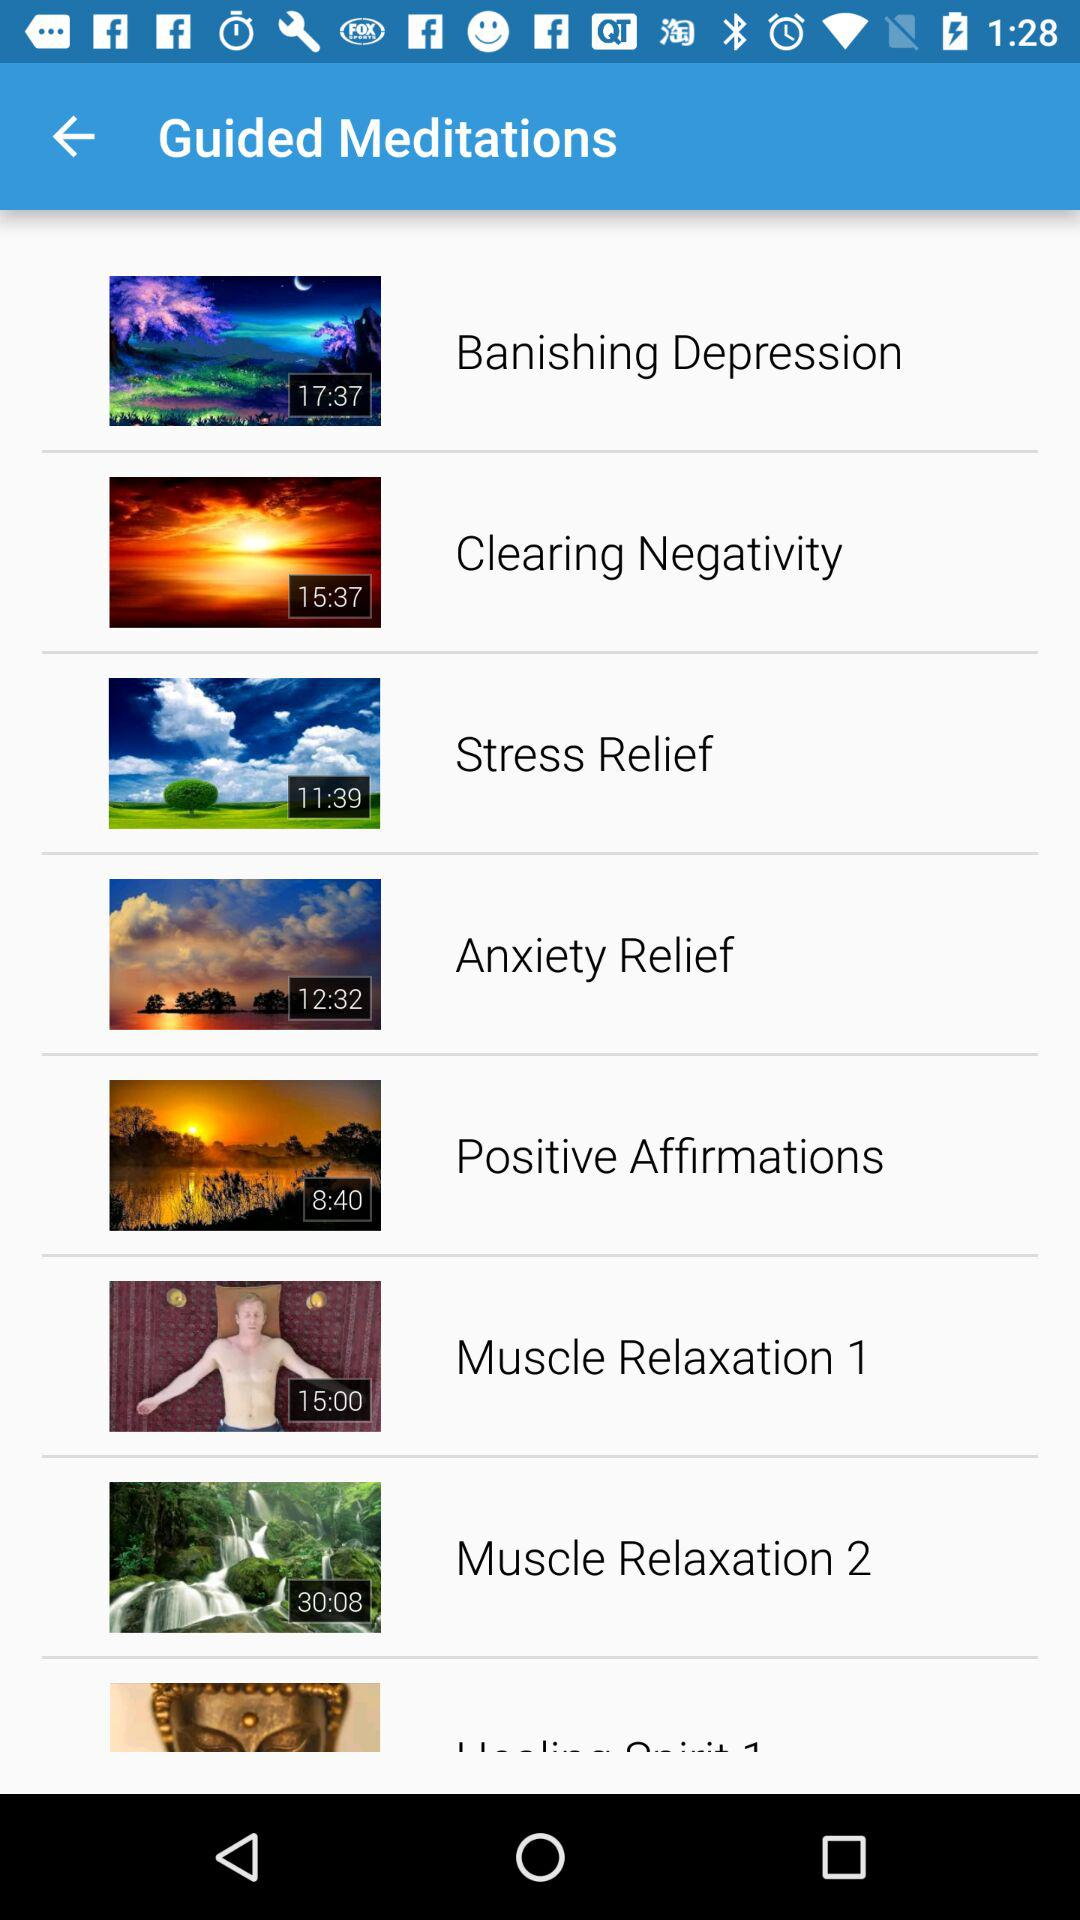What is the duration of the "Clearing Negativity" meditation? The duration of the "Clearing Negativity" meditation is 15:37. 